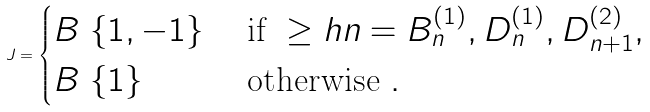Convert formula to latex. <formula><loc_0><loc_0><loc_500><loc_500>J = \begin{cases} B \ \{ 1 , - 1 \} & \text { if } \geq h n = B ^ { ( 1 ) } _ { n } , D ^ { ( 1 ) } _ { n } , D ^ { ( 2 ) } _ { n + 1 } , \\ B \ \{ 1 \} & \text { otherwise } . \end{cases}</formula> 